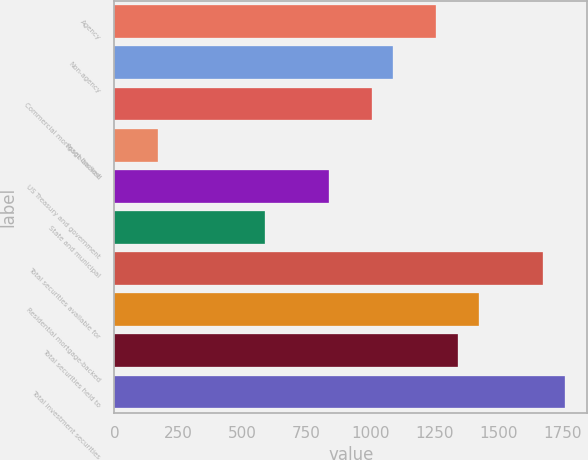Convert chart. <chart><loc_0><loc_0><loc_500><loc_500><bar_chart><fcel>Agency<fcel>Non-agency<fcel>Commercial mortgage-backed<fcel>Asset-backed<fcel>US Treasury and government<fcel>State and municipal<fcel>Total securities available for<fcel>Residential mortgage-backed<fcel>Total securities held to<fcel>Total investment securities<nl><fcel>1256.5<fcel>1089.1<fcel>1005.4<fcel>168.4<fcel>838<fcel>586.9<fcel>1675<fcel>1423.9<fcel>1340.2<fcel>1758.7<nl></chart> 